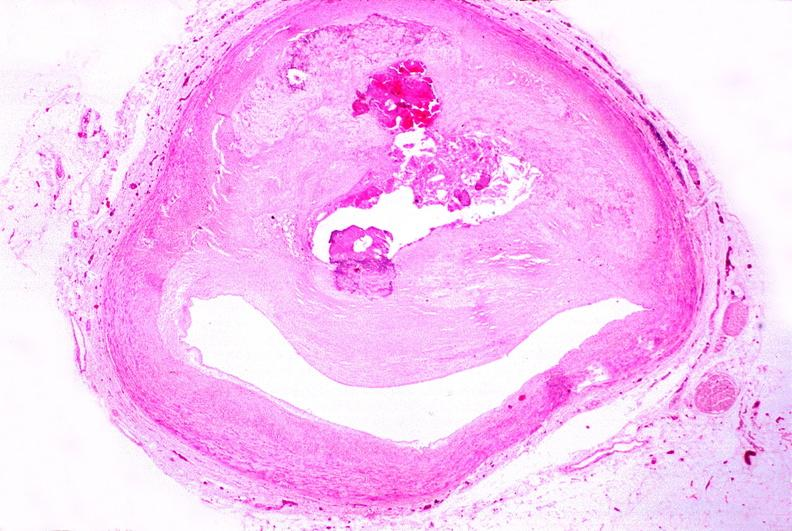what left anterior descending coronary artery?
Answer the question using a single word or phrase. Atherosclerosis 